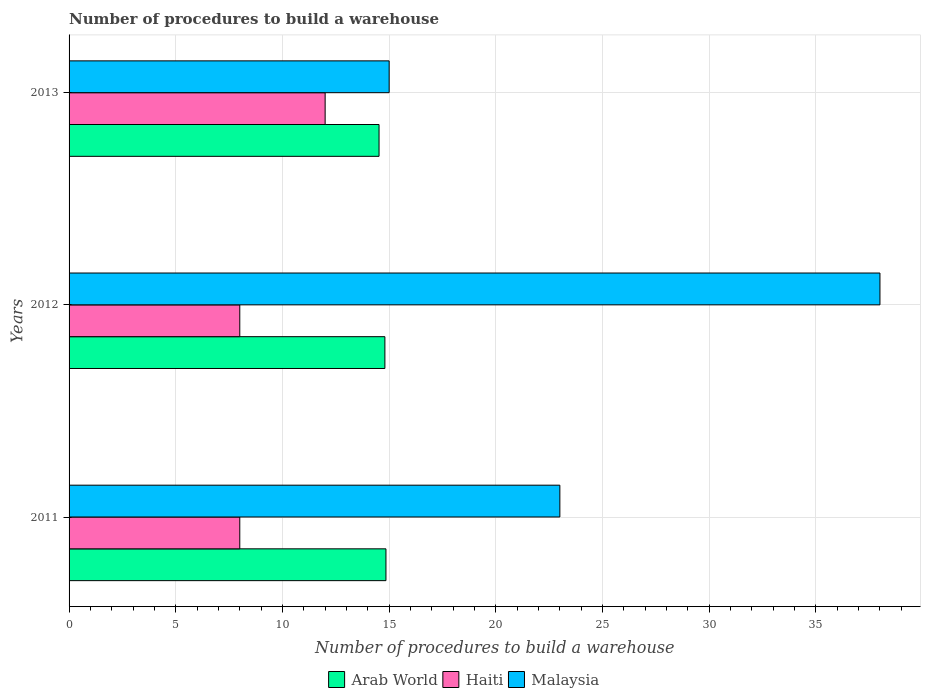Are the number of bars per tick equal to the number of legend labels?
Ensure brevity in your answer.  Yes. What is the number of procedures to build a warehouse in in Arab World in 2011?
Your answer should be compact. 14.85. Across all years, what is the maximum number of procedures to build a warehouse in in Malaysia?
Your response must be concise. 38. Across all years, what is the minimum number of procedures to build a warehouse in in Malaysia?
Make the answer very short. 15. What is the total number of procedures to build a warehouse in in Arab World in the graph?
Your response must be concise. 44.18. What is the difference between the number of procedures to build a warehouse in in Malaysia in 2012 and that in 2013?
Provide a succinct answer. 23. What is the difference between the number of procedures to build a warehouse in in Malaysia in 2011 and the number of procedures to build a warehouse in in Arab World in 2012?
Keep it short and to the point. 8.2. What is the average number of procedures to build a warehouse in in Arab World per year?
Provide a short and direct response. 14.73. In the year 2012, what is the difference between the number of procedures to build a warehouse in in Malaysia and number of procedures to build a warehouse in in Haiti?
Ensure brevity in your answer.  30. What is the ratio of the number of procedures to build a warehouse in in Arab World in 2011 to that in 2012?
Give a very brief answer. 1. What is the difference between the highest and the lowest number of procedures to build a warehouse in in Arab World?
Provide a succinct answer. 0.32. What does the 3rd bar from the top in 2013 represents?
Keep it short and to the point. Arab World. What does the 1st bar from the bottom in 2011 represents?
Offer a terse response. Arab World. How many bars are there?
Your answer should be very brief. 9. Are all the bars in the graph horizontal?
Your answer should be very brief. Yes. How many years are there in the graph?
Keep it short and to the point. 3. What is the difference between two consecutive major ticks on the X-axis?
Give a very brief answer. 5. Does the graph contain grids?
Keep it short and to the point. Yes. How many legend labels are there?
Your response must be concise. 3. What is the title of the graph?
Give a very brief answer. Number of procedures to build a warehouse. What is the label or title of the X-axis?
Ensure brevity in your answer.  Number of procedures to build a warehouse. What is the Number of procedures to build a warehouse in Arab World in 2011?
Provide a succinct answer. 14.85. What is the Number of procedures to build a warehouse in Malaysia in 2011?
Offer a terse response. 23. What is the Number of procedures to build a warehouse in Haiti in 2012?
Your answer should be compact. 8. What is the Number of procedures to build a warehouse in Malaysia in 2012?
Your answer should be compact. 38. What is the Number of procedures to build a warehouse in Arab World in 2013?
Your answer should be compact. 14.53. What is the Number of procedures to build a warehouse in Haiti in 2013?
Provide a short and direct response. 12. Across all years, what is the maximum Number of procedures to build a warehouse of Arab World?
Offer a very short reply. 14.85. Across all years, what is the maximum Number of procedures to build a warehouse in Malaysia?
Your answer should be compact. 38. Across all years, what is the minimum Number of procedures to build a warehouse in Arab World?
Provide a short and direct response. 14.53. What is the total Number of procedures to build a warehouse in Arab World in the graph?
Offer a terse response. 44.18. What is the total Number of procedures to build a warehouse in Haiti in the graph?
Provide a short and direct response. 28. What is the total Number of procedures to build a warehouse of Malaysia in the graph?
Your response must be concise. 76. What is the difference between the Number of procedures to build a warehouse of Arab World in 2011 and that in 2012?
Ensure brevity in your answer.  0.05. What is the difference between the Number of procedures to build a warehouse of Haiti in 2011 and that in 2012?
Your answer should be compact. 0. What is the difference between the Number of procedures to build a warehouse of Malaysia in 2011 and that in 2012?
Make the answer very short. -15. What is the difference between the Number of procedures to build a warehouse of Arab World in 2011 and that in 2013?
Make the answer very short. 0.32. What is the difference between the Number of procedures to build a warehouse of Haiti in 2011 and that in 2013?
Your response must be concise. -4. What is the difference between the Number of procedures to build a warehouse of Arab World in 2012 and that in 2013?
Make the answer very short. 0.27. What is the difference between the Number of procedures to build a warehouse of Haiti in 2012 and that in 2013?
Offer a terse response. -4. What is the difference between the Number of procedures to build a warehouse of Arab World in 2011 and the Number of procedures to build a warehouse of Haiti in 2012?
Your answer should be compact. 6.85. What is the difference between the Number of procedures to build a warehouse of Arab World in 2011 and the Number of procedures to build a warehouse of Malaysia in 2012?
Provide a succinct answer. -23.15. What is the difference between the Number of procedures to build a warehouse in Haiti in 2011 and the Number of procedures to build a warehouse in Malaysia in 2012?
Your answer should be compact. -30. What is the difference between the Number of procedures to build a warehouse of Arab World in 2011 and the Number of procedures to build a warehouse of Haiti in 2013?
Your answer should be very brief. 2.85. What is the difference between the Number of procedures to build a warehouse of Haiti in 2011 and the Number of procedures to build a warehouse of Malaysia in 2013?
Make the answer very short. -7. What is the difference between the Number of procedures to build a warehouse in Arab World in 2012 and the Number of procedures to build a warehouse in Haiti in 2013?
Give a very brief answer. 2.8. What is the difference between the Number of procedures to build a warehouse in Haiti in 2012 and the Number of procedures to build a warehouse in Malaysia in 2013?
Give a very brief answer. -7. What is the average Number of procedures to build a warehouse of Arab World per year?
Ensure brevity in your answer.  14.73. What is the average Number of procedures to build a warehouse in Haiti per year?
Your answer should be very brief. 9.33. What is the average Number of procedures to build a warehouse in Malaysia per year?
Your response must be concise. 25.33. In the year 2011, what is the difference between the Number of procedures to build a warehouse in Arab World and Number of procedures to build a warehouse in Haiti?
Your response must be concise. 6.85. In the year 2011, what is the difference between the Number of procedures to build a warehouse in Arab World and Number of procedures to build a warehouse in Malaysia?
Your answer should be compact. -8.15. In the year 2011, what is the difference between the Number of procedures to build a warehouse of Haiti and Number of procedures to build a warehouse of Malaysia?
Your answer should be very brief. -15. In the year 2012, what is the difference between the Number of procedures to build a warehouse of Arab World and Number of procedures to build a warehouse of Malaysia?
Give a very brief answer. -23.2. In the year 2012, what is the difference between the Number of procedures to build a warehouse of Haiti and Number of procedures to build a warehouse of Malaysia?
Provide a short and direct response. -30. In the year 2013, what is the difference between the Number of procedures to build a warehouse of Arab World and Number of procedures to build a warehouse of Haiti?
Provide a succinct answer. 2.53. In the year 2013, what is the difference between the Number of procedures to build a warehouse in Arab World and Number of procedures to build a warehouse in Malaysia?
Your answer should be compact. -0.47. In the year 2013, what is the difference between the Number of procedures to build a warehouse of Haiti and Number of procedures to build a warehouse of Malaysia?
Your answer should be compact. -3. What is the ratio of the Number of procedures to build a warehouse of Haiti in 2011 to that in 2012?
Your response must be concise. 1. What is the ratio of the Number of procedures to build a warehouse in Malaysia in 2011 to that in 2012?
Offer a terse response. 0.61. What is the ratio of the Number of procedures to build a warehouse in Arab World in 2011 to that in 2013?
Ensure brevity in your answer.  1.02. What is the ratio of the Number of procedures to build a warehouse in Haiti in 2011 to that in 2013?
Make the answer very short. 0.67. What is the ratio of the Number of procedures to build a warehouse of Malaysia in 2011 to that in 2013?
Your response must be concise. 1.53. What is the ratio of the Number of procedures to build a warehouse in Arab World in 2012 to that in 2013?
Your response must be concise. 1.02. What is the ratio of the Number of procedures to build a warehouse of Haiti in 2012 to that in 2013?
Ensure brevity in your answer.  0.67. What is the ratio of the Number of procedures to build a warehouse in Malaysia in 2012 to that in 2013?
Your answer should be very brief. 2.53. What is the difference between the highest and the second highest Number of procedures to build a warehouse of Arab World?
Keep it short and to the point. 0.05. What is the difference between the highest and the second highest Number of procedures to build a warehouse in Haiti?
Offer a terse response. 4. What is the difference between the highest and the second highest Number of procedures to build a warehouse of Malaysia?
Your answer should be compact. 15. What is the difference between the highest and the lowest Number of procedures to build a warehouse of Arab World?
Provide a succinct answer. 0.32. What is the difference between the highest and the lowest Number of procedures to build a warehouse of Malaysia?
Keep it short and to the point. 23. 